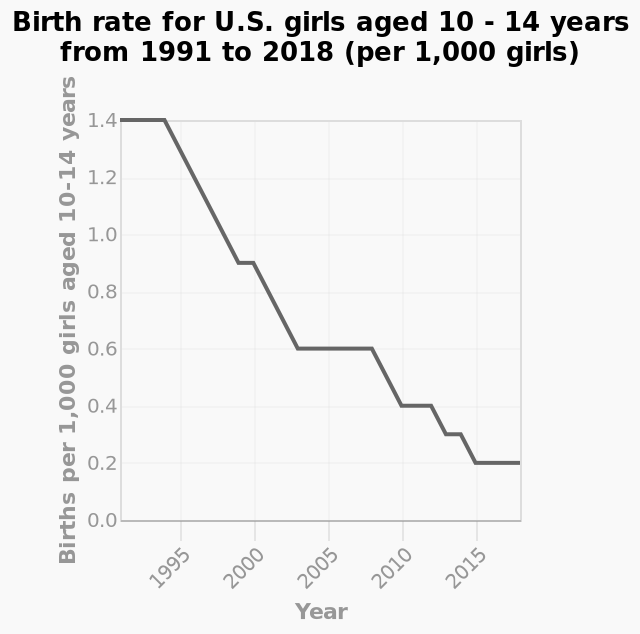<image>
What trend has been observed in the number of births per 1,000 girls aged 10-14 years from 1991 to 2018?  There has been an overall decline in the number of births per 1,000 girls aged 10-14 years from 1991 to 2018. please summary the statistics and relations of the chart There has been an overall decline in Births per 1,000 girls aged 10-14 years from 1991 to 2018. The biggest decline was between 1994 and 2002. It did stabilised between 2002 and 2009 and then has gradually declined since then. 